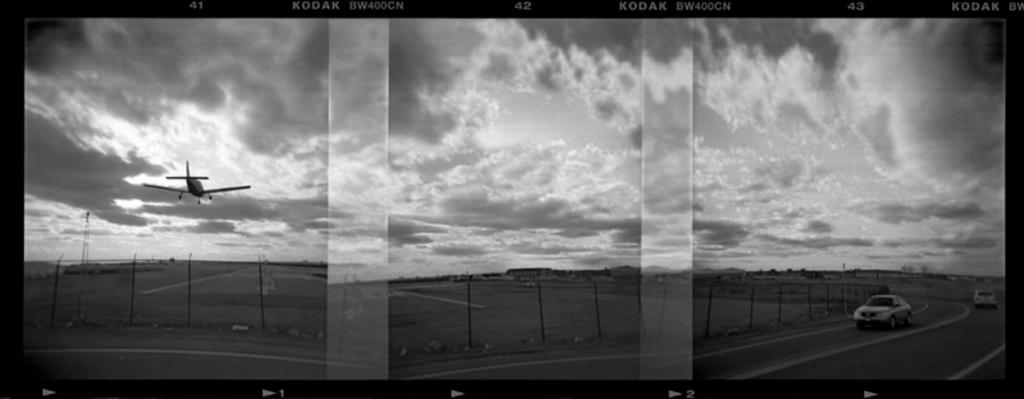Provide a one-sentence caption for the provided image. three black and white images of a desolate road on KODAK paper. 